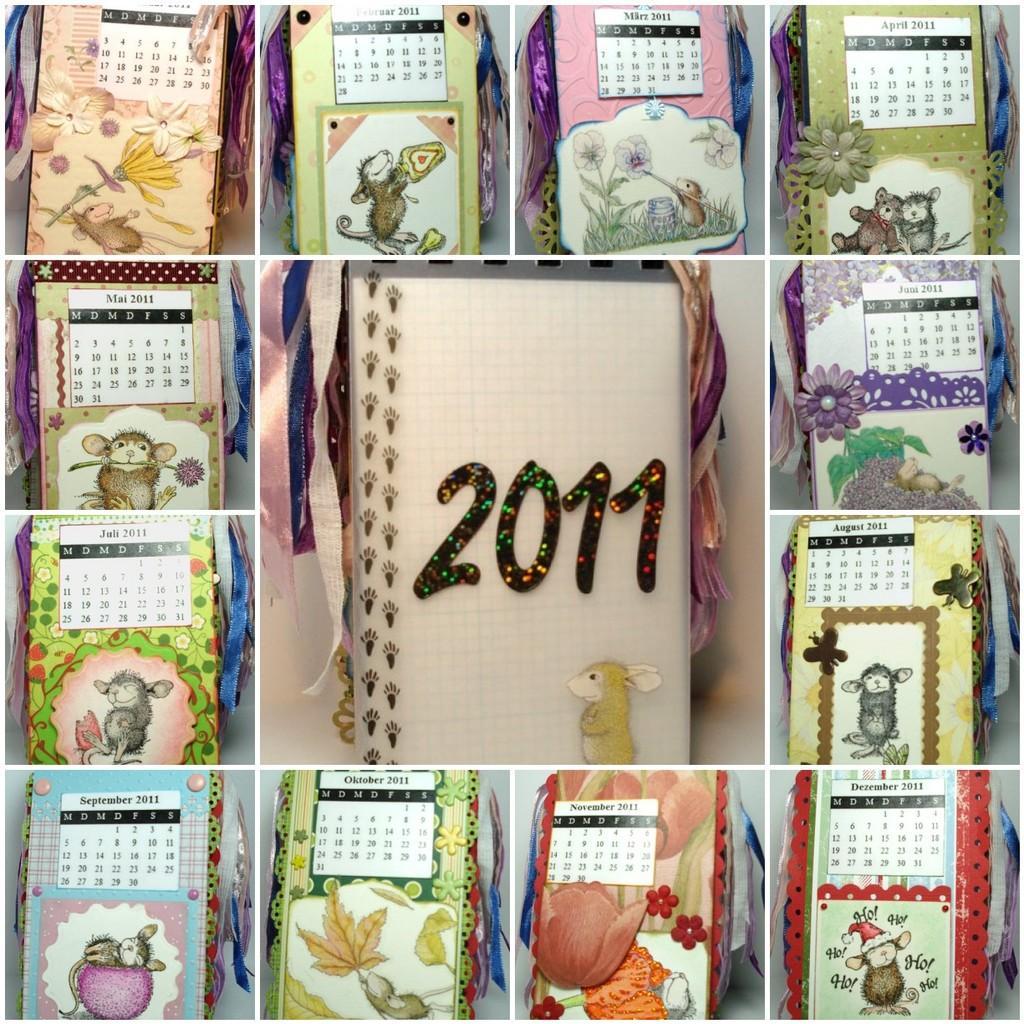Please provide a concise description of this image. In this picture, it seems like a collage of calendar. 